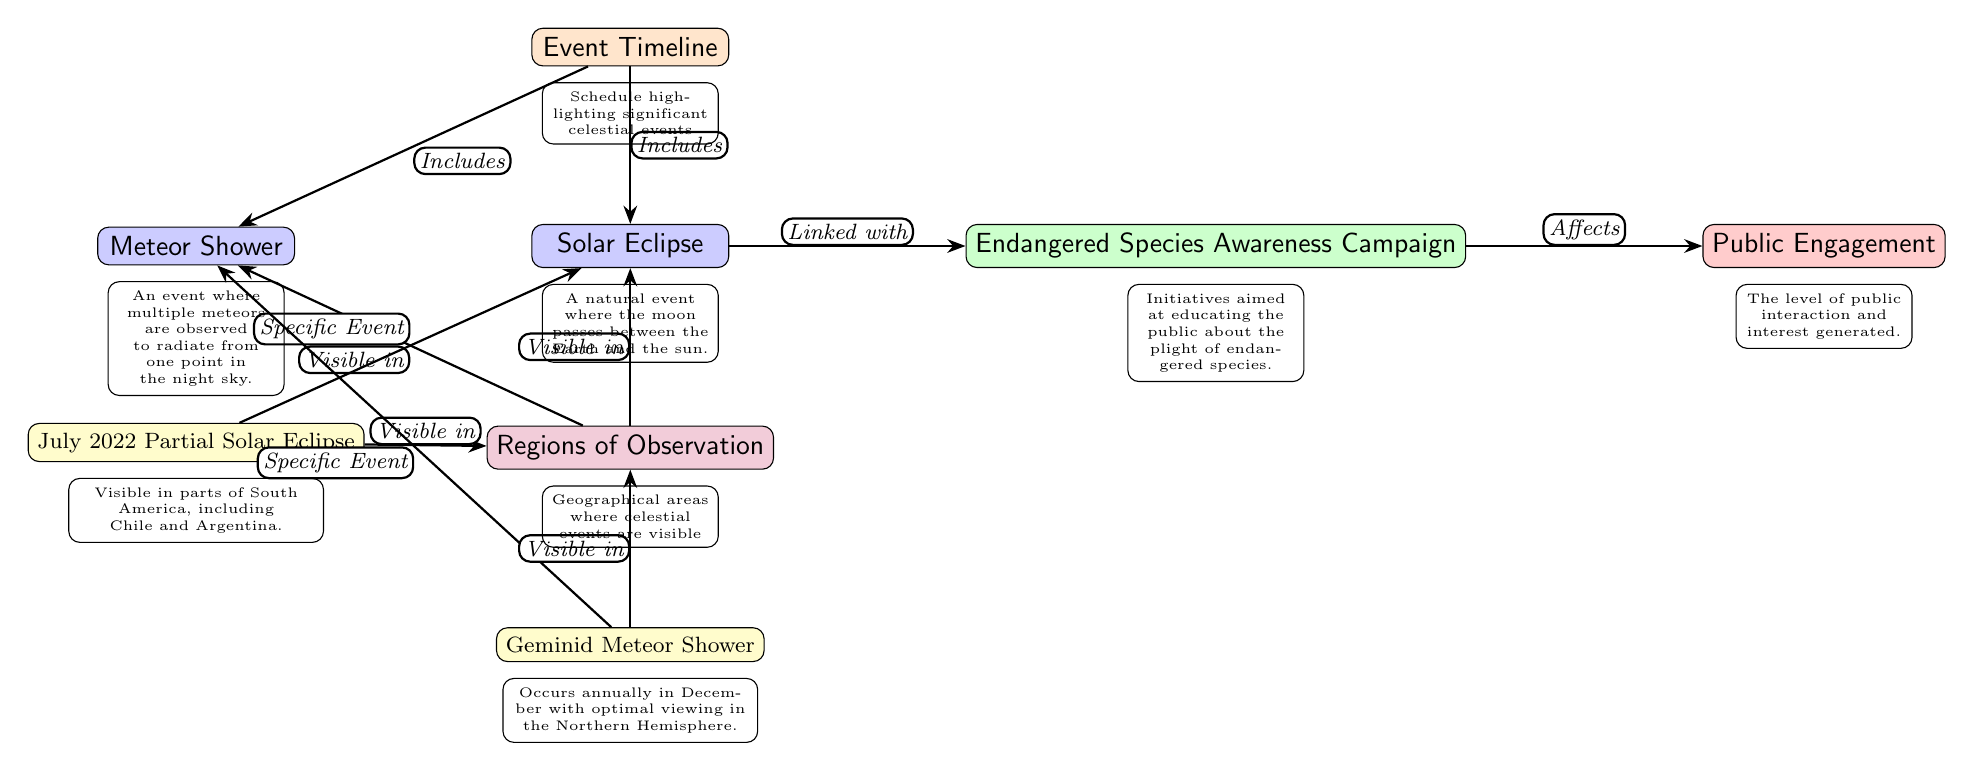What celestial event is linked with the campaign? The diagram indicates a direct relationship labeled "Linked with" between the Solar Eclipse node and the Endangered Species Awareness Campaign node.
Answer: Solar Eclipse How many specific events are listed in the diagram? There are two specific events mentioned: the July 2022 Partial Solar Eclipse and the Geminid Meteor Shower, both of which are explicitly labeled in the diagram.
Answer: 2 Which region is indicated for the July 2022 Partial Solar Eclipse? The diagram specifies that the July 2022 Partial Solar Eclipse is "Visible in" parts of South America including Chile and Argentina, showing a clear connection between the event and the region.
Answer: South America What does the timeline node include? The timeline node connects to both the Solar Eclipse and the Meteor Shower nodes with arrows labeled "Includes", suggesting the timeline comprises significant celestial events reflected in those nodes.
Answer: Solar Eclipse, Meteor Shower How does the Endangered Species Awareness Campaign affect public engagement? According to the diagram, there is a direct edge labeled "Affects" between the Endangered Species Awareness Campaign node and the Public Engagement node, implying a relationship where the campaign impacts public interest.
Answer: Public Engagement Which meteor shower is mentioned as a specific event? The diagram features the Geminid Meteor Shower as a specific event connected to the Meteor Shower node with a labeled edge "Specific Event".
Answer: Geminid Meteor Shower What type of celestial event occurs when the moon passes between the Earth and the sun? The diagram elaborates on the Solar Eclipse with a description stating that it occurs when the moon is positioned between the Earth and the sun.
Answer: Solar Eclipse Where are the regions of observation for the Geminid Meteor Shower? The diagram notes that the Geminid Meteor Shower is "Visible in" the region, but does not specify which geographical areas, indicating a broader but unspecified range for visibility.
Answer: (Not specified) What is the role of the engagement node in the diagram? The engagement node is connected to the Endangered Species Awareness Campaign node via an edge labeled "Affects", showing that the campaign serves to raise or influence public engagement regarding endangered species.
Answer: Public Engagement 